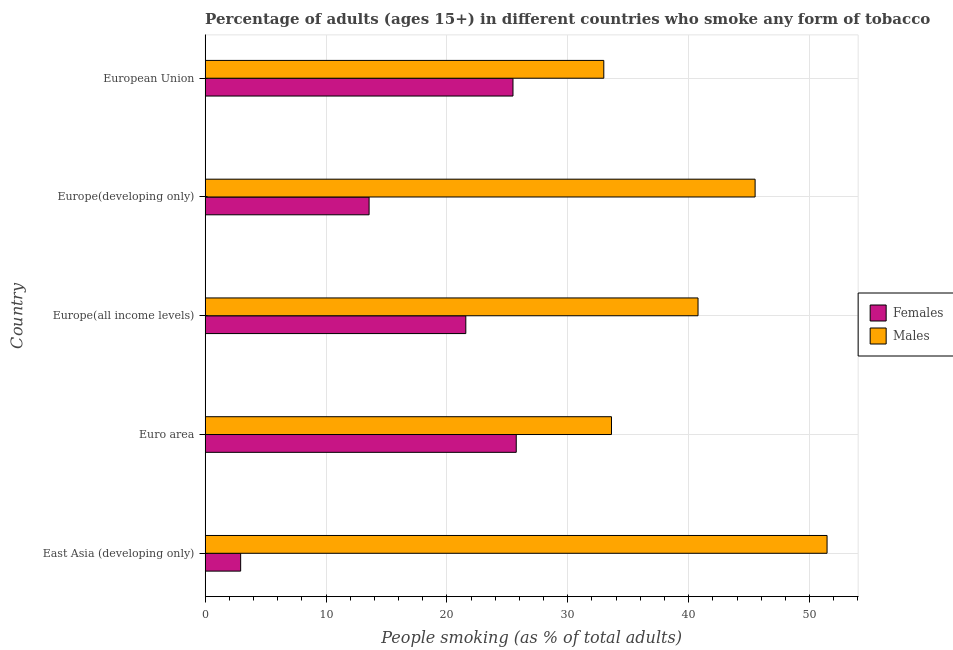How many groups of bars are there?
Your response must be concise. 5. What is the label of the 3rd group of bars from the top?
Your answer should be compact. Europe(all income levels). In how many cases, is the number of bars for a given country not equal to the number of legend labels?
Keep it short and to the point. 0. What is the percentage of males who smoke in East Asia (developing only)?
Provide a short and direct response. 51.45. Across all countries, what is the maximum percentage of females who smoke?
Make the answer very short. 25.73. Across all countries, what is the minimum percentage of females who smoke?
Provide a succinct answer. 2.93. In which country was the percentage of females who smoke maximum?
Provide a succinct answer. Euro area. In which country was the percentage of females who smoke minimum?
Make the answer very short. East Asia (developing only). What is the total percentage of females who smoke in the graph?
Provide a short and direct response. 89.25. What is the difference between the percentage of males who smoke in East Asia (developing only) and that in Europe(developing only)?
Your answer should be very brief. 5.95. What is the difference between the percentage of males who smoke in East Asia (developing only) and the percentage of females who smoke in European Union?
Offer a very short reply. 25.98. What is the average percentage of females who smoke per country?
Offer a very short reply. 17.85. What is the difference between the percentage of females who smoke and percentage of males who smoke in Euro area?
Keep it short and to the point. -7.88. What is the ratio of the percentage of females who smoke in East Asia (developing only) to that in Euro area?
Your answer should be very brief. 0.11. Is the percentage of females who smoke in East Asia (developing only) less than that in Euro area?
Your response must be concise. Yes. What is the difference between the highest and the second highest percentage of females who smoke?
Your answer should be compact. 0.27. What is the difference between the highest and the lowest percentage of males who smoke?
Ensure brevity in your answer.  18.47. In how many countries, is the percentage of males who smoke greater than the average percentage of males who smoke taken over all countries?
Your answer should be compact. 2. What does the 2nd bar from the top in East Asia (developing only) represents?
Your answer should be very brief. Females. What does the 1st bar from the bottom in European Union represents?
Offer a very short reply. Females. Are all the bars in the graph horizontal?
Make the answer very short. Yes. Does the graph contain any zero values?
Offer a very short reply. No. Does the graph contain grids?
Your answer should be very brief. Yes. What is the title of the graph?
Make the answer very short. Percentage of adults (ages 15+) in different countries who smoke any form of tobacco. What is the label or title of the X-axis?
Your answer should be very brief. People smoking (as % of total adults). What is the label or title of the Y-axis?
Ensure brevity in your answer.  Country. What is the People smoking (as % of total adults) of Females in East Asia (developing only)?
Provide a short and direct response. 2.93. What is the People smoking (as % of total adults) in Males in East Asia (developing only)?
Offer a very short reply. 51.45. What is the People smoking (as % of total adults) in Females in Euro area?
Your answer should be compact. 25.73. What is the People smoking (as % of total adults) of Males in Euro area?
Give a very brief answer. 33.61. What is the People smoking (as % of total adults) in Females in Europe(all income levels)?
Your answer should be compact. 21.56. What is the People smoking (as % of total adults) of Males in Europe(all income levels)?
Ensure brevity in your answer.  40.77. What is the People smoking (as % of total adults) in Females in Europe(developing only)?
Keep it short and to the point. 13.56. What is the People smoking (as % of total adults) in Males in Europe(developing only)?
Keep it short and to the point. 45.5. What is the People smoking (as % of total adults) in Females in European Union?
Give a very brief answer. 25.46. What is the People smoking (as % of total adults) in Males in European Union?
Offer a terse response. 32.98. Across all countries, what is the maximum People smoking (as % of total adults) of Females?
Your response must be concise. 25.73. Across all countries, what is the maximum People smoking (as % of total adults) in Males?
Provide a short and direct response. 51.45. Across all countries, what is the minimum People smoking (as % of total adults) of Females?
Your answer should be compact. 2.93. Across all countries, what is the minimum People smoking (as % of total adults) of Males?
Your answer should be very brief. 32.98. What is the total People smoking (as % of total adults) in Females in the graph?
Offer a terse response. 89.25. What is the total People smoking (as % of total adults) in Males in the graph?
Give a very brief answer. 204.31. What is the difference between the People smoking (as % of total adults) of Females in East Asia (developing only) and that in Euro area?
Your answer should be compact. -22.8. What is the difference between the People smoking (as % of total adults) of Males in East Asia (developing only) and that in Euro area?
Give a very brief answer. 17.84. What is the difference between the People smoking (as % of total adults) in Females in East Asia (developing only) and that in Europe(all income levels)?
Provide a short and direct response. -18.63. What is the difference between the People smoking (as % of total adults) in Males in East Asia (developing only) and that in Europe(all income levels)?
Make the answer very short. 10.67. What is the difference between the People smoking (as % of total adults) in Females in East Asia (developing only) and that in Europe(developing only)?
Keep it short and to the point. -10.63. What is the difference between the People smoking (as % of total adults) of Males in East Asia (developing only) and that in Europe(developing only)?
Ensure brevity in your answer.  5.95. What is the difference between the People smoking (as % of total adults) of Females in East Asia (developing only) and that in European Union?
Make the answer very short. -22.53. What is the difference between the People smoking (as % of total adults) in Males in East Asia (developing only) and that in European Union?
Provide a short and direct response. 18.47. What is the difference between the People smoking (as % of total adults) of Females in Euro area and that in Europe(all income levels)?
Your answer should be very brief. 4.17. What is the difference between the People smoking (as % of total adults) of Males in Euro area and that in Europe(all income levels)?
Provide a succinct answer. -7.16. What is the difference between the People smoking (as % of total adults) of Females in Euro area and that in Europe(developing only)?
Ensure brevity in your answer.  12.17. What is the difference between the People smoking (as % of total adults) of Males in Euro area and that in Europe(developing only)?
Your answer should be compact. -11.88. What is the difference between the People smoking (as % of total adults) in Females in Euro area and that in European Union?
Ensure brevity in your answer.  0.27. What is the difference between the People smoking (as % of total adults) in Males in Euro area and that in European Union?
Your answer should be compact. 0.64. What is the difference between the People smoking (as % of total adults) in Females in Europe(all income levels) and that in Europe(developing only)?
Make the answer very short. 8. What is the difference between the People smoking (as % of total adults) of Males in Europe(all income levels) and that in Europe(developing only)?
Offer a very short reply. -4.72. What is the difference between the People smoking (as % of total adults) in Females in Europe(all income levels) and that in European Union?
Make the answer very short. -3.9. What is the difference between the People smoking (as % of total adults) of Males in Europe(all income levels) and that in European Union?
Ensure brevity in your answer.  7.8. What is the difference between the People smoking (as % of total adults) in Females in Europe(developing only) and that in European Union?
Give a very brief answer. -11.9. What is the difference between the People smoking (as % of total adults) of Males in Europe(developing only) and that in European Union?
Give a very brief answer. 12.52. What is the difference between the People smoking (as % of total adults) in Females in East Asia (developing only) and the People smoking (as % of total adults) in Males in Euro area?
Give a very brief answer. -30.68. What is the difference between the People smoking (as % of total adults) of Females in East Asia (developing only) and the People smoking (as % of total adults) of Males in Europe(all income levels)?
Keep it short and to the point. -37.84. What is the difference between the People smoking (as % of total adults) of Females in East Asia (developing only) and the People smoking (as % of total adults) of Males in Europe(developing only)?
Offer a terse response. -42.56. What is the difference between the People smoking (as % of total adults) in Females in East Asia (developing only) and the People smoking (as % of total adults) in Males in European Union?
Offer a very short reply. -30.04. What is the difference between the People smoking (as % of total adults) in Females in Euro area and the People smoking (as % of total adults) in Males in Europe(all income levels)?
Provide a succinct answer. -15.04. What is the difference between the People smoking (as % of total adults) of Females in Euro area and the People smoking (as % of total adults) of Males in Europe(developing only)?
Your answer should be very brief. -19.76. What is the difference between the People smoking (as % of total adults) of Females in Euro area and the People smoking (as % of total adults) of Males in European Union?
Offer a terse response. -7.24. What is the difference between the People smoking (as % of total adults) of Females in Europe(all income levels) and the People smoking (as % of total adults) of Males in Europe(developing only)?
Keep it short and to the point. -23.93. What is the difference between the People smoking (as % of total adults) of Females in Europe(all income levels) and the People smoking (as % of total adults) of Males in European Union?
Provide a short and direct response. -11.42. What is the difference between the People smoking (as % of total adults) of Females in Europe(developing only) and the People smoking (as % of total adults) of Males in European Union?
Offer a terse response. -19.42. What is the average People smoking (as % of total adults) in Females per country?
Provide a short and direct response. 17.85. What is the average People smoking (as % of total adults) of Males per country?
Your response must be concise. 40.86. What is the difference between the People smoking (as % of total adults) of Females and People smoking (as % of total adults) of Males in East Asia (developing only)?
Keep it short and to the point. -48.52. What is the difference between the People smoking (as % of total adults) in Females and People smoking (as % of total adults) in Males in Euro area?
Ensure brevity in your answer.  -7.88. What is the difference between the People smoking (as % of total adults) in Females and People smoking (as % of total adults) in Males in Europe(all income levels)?
Provide a short and direct response. -19.21. What is the difference between the People smoking (as % of total adults) in Females and People smoking (as % of total adults) in Males in Europe(developing only)?
Your answer should be very brief. -31.94. What is the difference between the People smoking (as % of total adults) in Females and People smoking (as % of total adults) in Males in European Union?
Provide a succinct answer. -7.51. What is the ratio of the People smoking (as % of total adults) of Females in East Asia (developing only) to that in Euro area?
Offer a very short reply. 0.11. What is the ratio of the People smoking (as % of total adults) of Males in East Asia (developing only) to that in Euro area?
Provide a succinct answer. 1.53. What is the ratio of the People smoking (as % of total adults) of Females in East Asia (developing only) to that in Europe(all income levels)?
Provide a succinct answer. 0.14. What is the ratio of the People smoking (as % of total adults) of Males in East Asia (developing only) to that in Europe(all income levels)?
Offer a very short reply. 1.26. What is the ratio of the People smoking (as % of total adults) in Females in East Asia (developing only) to that in Europe(developing only)?
Keep it short and to the point. 0.22. What is the ratio of the People smoking (as % of total adults) of Males in East Asia (developing only) to that in Europe(developing only)?
Ensure brevity in your answer.  1.13. What is the ratio of the People smoking (as % of total adults) of Females in East Asia (developing only) to that in European Union?
Give a very brief answer. 0.12. What is the ratio of the People smoking (as % of total adults) in Males in East Asia (developing only) to that in European Union?
Keep it short and to the point. 1.56. What is the ratio of the People smoking (as % of total adults) of Females in Euro area to that in Europe(all income levels)?
Provide a succinct answer. 1.19. What is the ratio of the People smoking (as % of total adults) of Males in Euro area to that in Europe(all income levels)?
Your response must be concise. 0.82. What is the ratio of the People smoking (as % of total adults) of Females in Euro area to that in Europe(developing only)?
Offer a terse response. 1.9. What is the ratio of the People smoking (as % of total adults) of Males in Euro area to that in Europe(developing only)?
Provide a succinct answer. 0.74. What is the ratio of the People smoking (as % of total adults) of Females in Euro area to that in European Union?
Your answer should be compact. 1.01. What is the ratio of the People smoking (as % of total adults) in Males in Euro area to that in European Union?
Offer a terse response. 1.02. What is the ratio of the People smoking (as % of total adults) in Females in Europe(all income levels) to that in Europe(developing only)?
Your answer should be very brief. 1.59. What is the ratio of the People smoking (as % of total adults) in Males in Europe(all income levels) to that in Europe(developing only)?
Provide a succinct answer. 0.9. What is the ratio of the People smoking (as % of total adults) of Females in Europe(all income levels) to that in European Union?
Provide a short and direct response. 0.85. What is the ratio of the People smoking (as % of total adults) of Males in Europe(all income levels) to that in European Union?
Your response must be concise. 1.24. What is the ratio of the People smoking (as % of total adults) in Females in Europe(developing only) to that in European Union?
Provide a short and direct response. 0.53. What is the ratio of the People smoking (as % of total adults) of Males in Europe(developing only) to that in European Union?
Offer a very short reply. 1.38. What is the difference between the highest and the second highest People smoking (as % of total adults) in Females?
Keep it short and to the point. 0.27. What is the difference between the highest and the second highest People smoking (as % of total adults) of Males?
Ensure brevity in your answer.  5.95. What is the difference between the highest and the lowest People smoking (as % of total adults) in Females?
Give a very brief answer. 22.8. What is the difference between the highest and the lowest People smoking (as % of total adults) of Males?
Give a very brief answer. 18.47. 